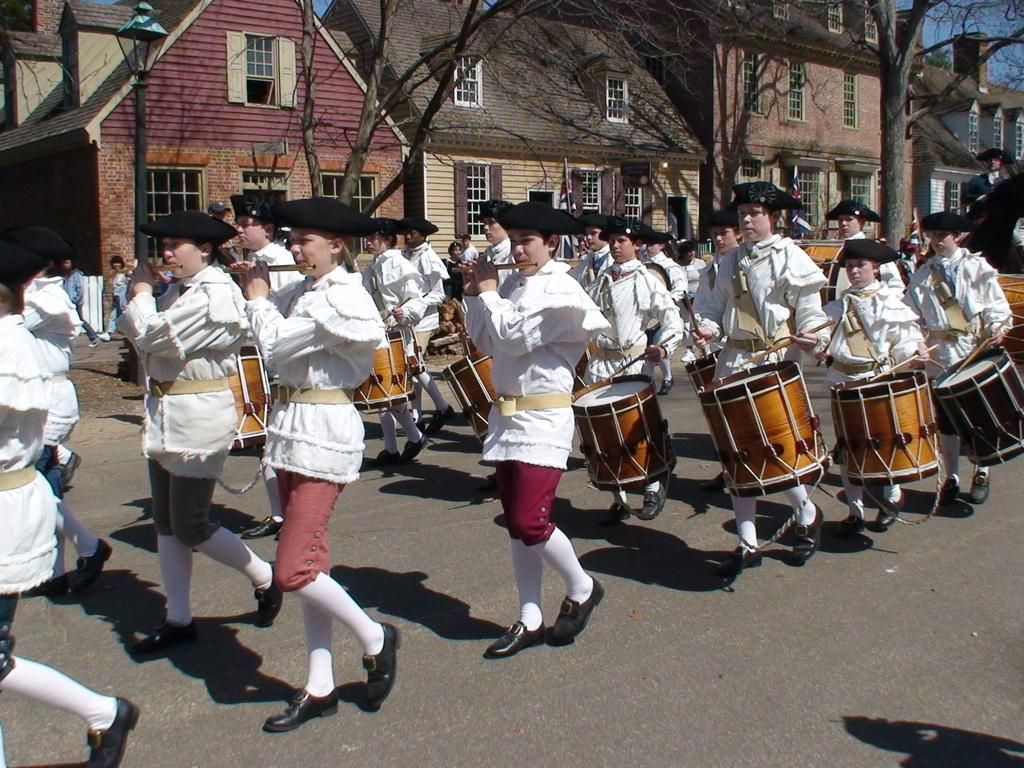What is happening in the image involving a group of people? The people in the image are playing a snare drum with drum sticks. What can be observed about the attire of the people in the image? The people are dressed in white. What structures are visible in the image? There is a house and trees in the image. What verse is being recited by the people in the image? There is no indication in the image that the people are reciting a verse; they are playing a snare drum. Can you see any necks in the image? There is no specific mention of necks in the image, but the people playing the drum may have visible necks as part of their bodies. However, the question is not directly related to the image's content. 